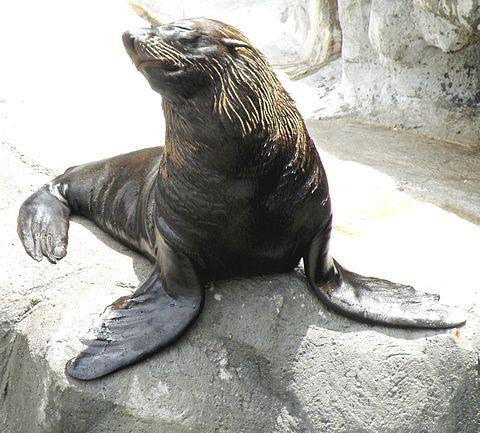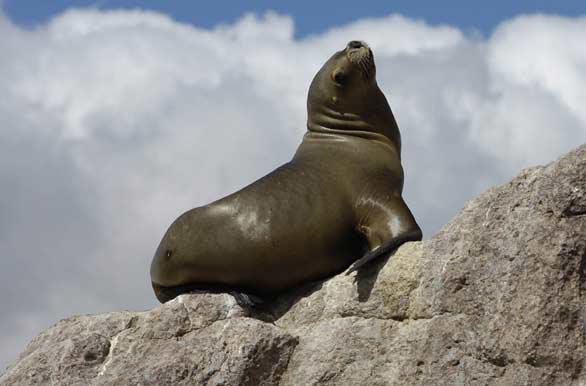The first image is the image on the left, the second image is the image on the right. For the images shown, is this caption "Each image contains one aquatic mammal perched on a rock, with upraised head and wet hide, and the animals in the left and right images face different directions." true? Answer yes or no. Yes. The first image is the image on the left, the second image is the image on the right. Examine the images to the left and right. Is the description "An image contains at least two seals." accurate? Answer yes or no. No. 